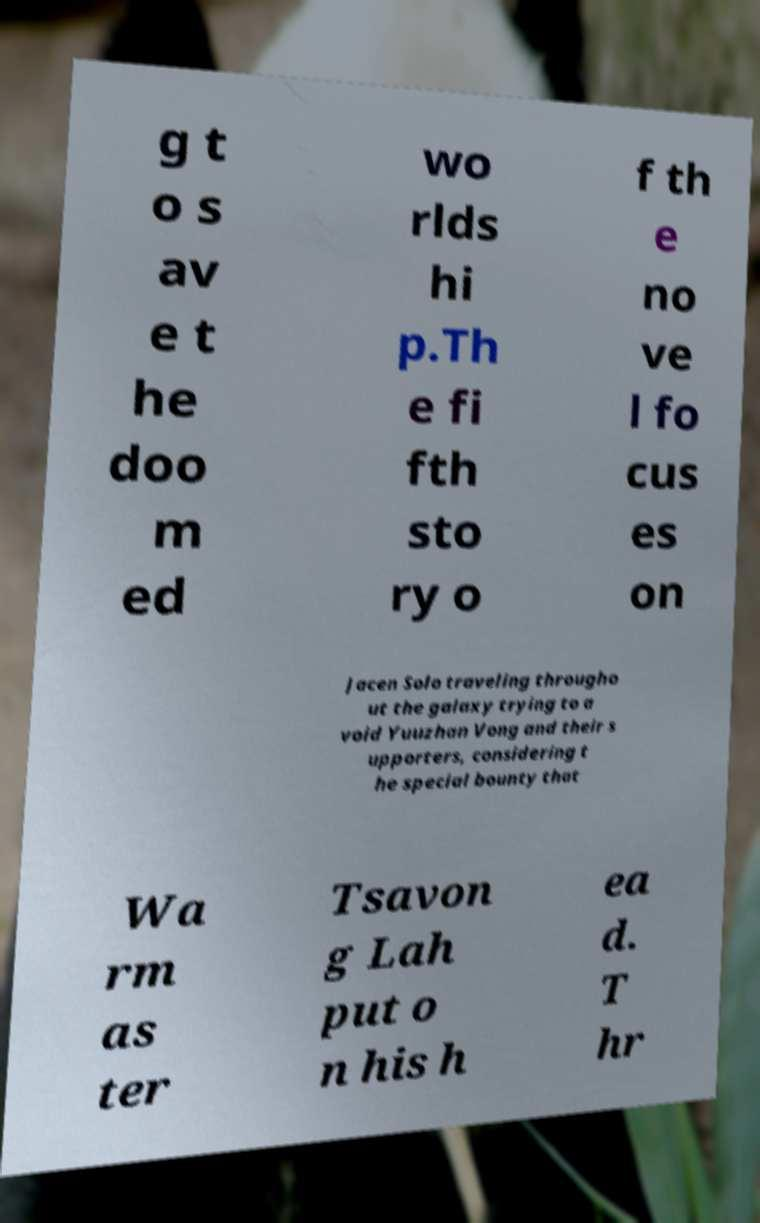Could you extract and type out the text from this image? g t o s av e t he doo m ed wo rlds hi p.Th e fi fth sto ry o f th e no ve l fo cus es on Jacen Solo traveling througho ut the galaxy trying to a void Yuuzhan Vong and their s upporters, considering t he special bounty that Wa rm as ter Tsavon g Lah put o n his h ea d. T hr 